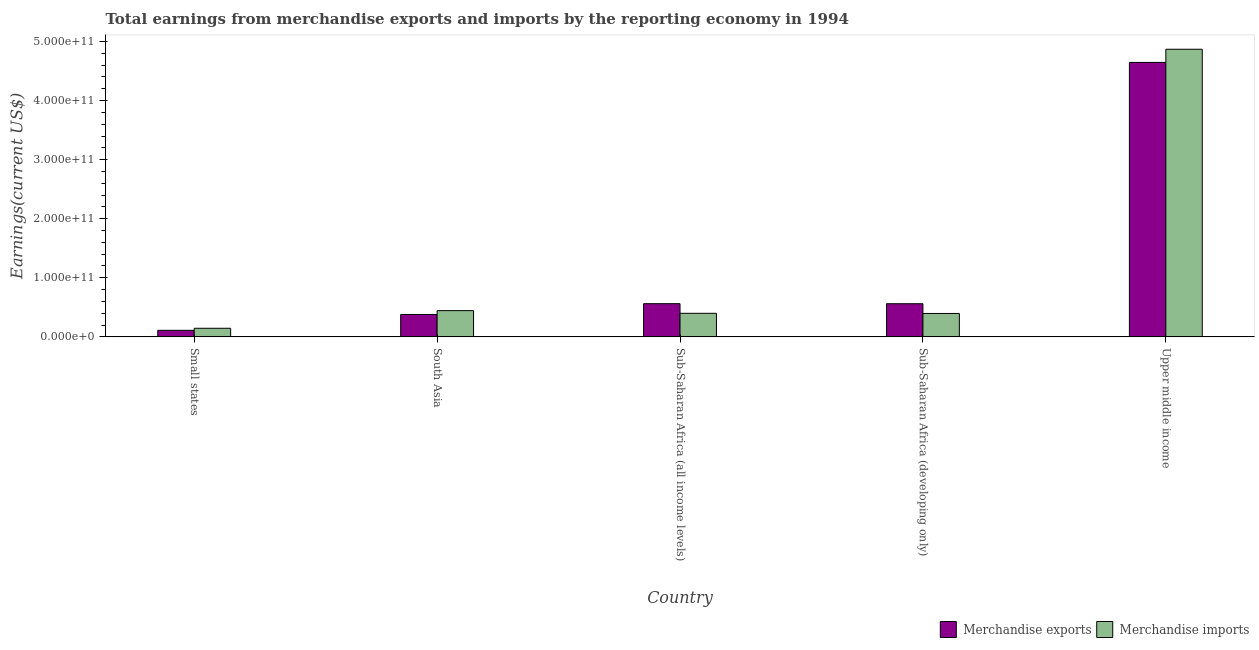Are the number of bars on each tick of the X-axis equal?
Your answer should be very brief. Yes. How many bars are there on the 3rd tick from the left?
Offer a very short reply. 2. What is the label of the 2nd group of bars from the left?
Make the answer very short. South Asia. What is the earnings from merchandise imports in Sub-Saharan Africa (developing only)?
Offer a terse response. 3.96e+1. Across all countries, what is the maximum earnings from merchandise imports?
Your response must be concise. 4.87e+11. Across all countries, what is the minimum earnings from merchandise imports?
Offer a very short reply. 1.45e+1. In which country was the earnings from merchandise exports maximum?
Your response must be concise. Upper middle income. In which country was the earnings from merchandise imports minimum?
Your answer should be compact. Small states. What is the total earnings from merchandise imports in the graph?
Offer a very short reply. 6.25e+11. What is the difference between the earnings from merchandise imports in South Asia and that in Sub-Saharan Africa (all income levels)?
Ensure brevity in your answer.  4.53e+09. What is the difference between the earnings from merchandise imports in Sub-Saharan Africa (developing only) and the earnings from merchandise exports in South Asia?
Your answer should be very brief. 1.75e+09. What is the average earnings from merchandise exports per country?
Make the answer very short. 1.25e+11. What is the difference between the earnings from merchandise imports and earnings from merchandise exports in Sub-Saharan Africa (all income levels)?
Make the answer very short. -1.63e+1. What is the ratio of the earnings from merchandise exports in Small states to that in Sub-Saharan Africa (developing only)?
Give a very brief answer. 0.2. What is the difference between the highest and the second highest earnings from merchandise imports?
Ensure brevity in your answer.  4.42e+11. What is the difference between the highest and the lowest earnings from merchandise imports?
Keep it short and to the point. 4.72e+11. Is the sum of the earnings from merchandise imports in Small states and South Asia greater than the maximum earnings from merchandise exports across all countries?
Keep it short and to the point. No. What does the 1st bar from the left in Upper middle income represents?
Make the answer very short. Merchandise exports. Are all the bars in the graph horizontal?
Offer a terse response. No. What is the difference between two consecutive major ticks on the Y-axis?
Provide a succinct answer. 1.00e+11. Are the values on the major ticks of Y-axis written in scientific E-notation?
Your response must be concise. Yes. Does the graph contain any zero values?
Your response must be concise. No. Where does the legend appear in the graph?
Provide a short and direct response. Bottom right. How are the legend labels stacked?
Your answer should be compact. Horizontal. What is the title of the graph?
Your answer should be very brief. Total earnings from merchandise exports and imports by the reporting economy in 1994. Does "Young" appear as one of the legend labels in the graph?
Ensure brevity in your answer.  No. What is the label or title of the Y-axis?
Provide a succinct answer. Earnings(current US$). What is the Earnings(current US$) of Merchandise exports in Small states?
Keep it short and to the point. 1.11e+1. What is the Earnings(current US$) in Merchandise imports in Small states?
Ensure brevity in your answer.  1.45e+1. What is the Earnings(current US$) in Merchandise exports in South Asia?
Offer a terse response. 3.79e+1. What is the Earnings(current US$) of Merchandise imports in South Asia?
Offer a very short reply. 4.44e+1. What is the Earnings(current US$) in Merchandise exports in Sub-Saharan Africa (all income levels)?
Offer a very short reply. 5.62e+1. What is the Earnings(current US$) in Merchandise imports in Sub-Saharan Africa (all income levels)?
Ensure brevity in your answer.  3.99e+1. What is the Earnings(current US$) of Merchandise exports in Sub-Saharan Africa (developing only)?
Provide a succinct answer. 5.61e+1. What is the Earnings(current US$) in Merchandise imports in Sub-Saharan Africa (developing only)?
Offer a very short reply. 3.96e+1. What is the Earnings(current US$) in Merchandise exports in Upper middle income?
Make the answer very short. 4.65e+11. What is the Earnings(current US$) in Merchandise imports in Upper middle income?
Provide a succinct answer. 4.87e+11. Across all countries, what is the maximum Earnings(current US$) of Merchandise exports?
Provide a succinct answer. 4.65e+11. Across all countries, what is the maximum Earnings(current US$) in Merchandise imports?
Your answer should be very brief. 4.87e+11. Across all countries, what is the minimum Earnings(current US$) of Merchandise exports?
Your response must be concise. 1.11e+1. Across all countries, what is the minimum Earnings(current US$) in Merchandise imports?
Provide a short and direct response. 1.45e+1. What is the total Earnings(current US$) in Merchandise exports in the graph?
Make the answer very short. 6.26e+11. What is the total Earnings(current US$) of Merchandise imports in the graph?
Offer a very short reply. 6.25e+11. What is the difference between the Earnings(current US$) of Merchandise exports in Small states and that in South Asia?
Your answer should be compact. -2.68e+1. What is the difference between the Earnings(current US$) in Merchandise imports in Small states and that in South Asia?
Provide a succinct answer. -2.99e+1. What is the difference between the Earnings(current US$) of Merchandise exports in Small states and that in Sub-Saharan Africa (all income levels)?
Your answer should be very brief. -4.51e+1. What is the difference between the Earnings(current US$) in Merchandise imports in Small states and that in Sub-Saharan Africa (all income levels)?
Provide a succinct answer. -2.54e+1. What is the difference between the Earnings(current US$) in Merchandise exports in Small states and that in Sub-Saharan Africa (developing only)?
Keep it short and to the point. -4.51e+1. What is the difference between the Earnings(current US$) of Merchandise imports in Small states and that in Sub-Saharan Africa (developing only)?
Provide a succinct answer. -2.51e+1. What is the difference between the Earnings(current US$) of Merchandise exports in Small states and that in Upper middle income?
Provide a short and direct response. -4.54e+11. What is the difference between the Earnings(current US$) in Merchandise imports in Small states and that in Upper middle income?
Your answer should be compact. -4.72e+11. What is the difference between the Earnings(current US$) in Merchandise exports in South Asia and that in Sub-Saharan Africa (all income levels)?
Your response must be concise. -1.83e+1. What is the difference between the Earnings(current US$) of Merchandise imports in South Asia and that in Sub-Saharan Africa (all income levels)?
Make the answer very short. 4.53e+09. What is the difference between the Earnings(current US$) in Merchandise exports in South Asia and that in Sub-Saharan Africa (developing only)?
Keep it short and to the point. -1.82e+1. What is the difference between the Earnings(current US$) in Merchandise imports in South Asia and that in Sub-Saharan Africa (developing only)?
Provide a short and direct response. 4.80e+09. What is the difference between the Earnings(current US$) in Merchandise exports in South Asia and that in Upper middle income?
Provide a succinct answer. -4.27e+11. What is the difference between the Earnings(current US$) in Merchandise imports in South Asia and that in Upper middle income?
Keep it short and to the point. -4.42e+11. What is the difference between the Earnings(current US$) in Merchandise exports in Sub-Saharan Africa (all income levels) and that in Sub-Saharan Africa (developing only)?
Offer a terse response. 7.79e+07. What is the difference between the Earnings(current US$) of Merchandise imports in Sub-Saharan Africa (all income levels) and that in Sub-Saharan Africa (developing only)?
Offer a terse response. 2.71e+08. What is the difference between the Earnings(current US$) of Merchandise exports in Sub-Saharan Africa (all income levels) and that in Upper middle income?
Keep it short and to the point. -4.08e+11. What is the difference between the Earnings(current US$) of Merchandise imports in Sub-Saharan Africa (all income levels) and that in Upper middle income?
Offer a terse response. -4.47e+11. What is the difference between the Earnings(current US$) of Merchandise exports in Sub-Saharan Africa (developing only) and that in Upper middle income?
Your answer should be compact. -4.09e+11. What is the difference between the Earnings(current US$) in Merchandise imports in Sub-Saharan Africa (developing only) and that in Upper middle income?
Give a very brief answer. -4.47e+11. What is the difference between the Earnings(current US$) of Merchandise exports in Small states and the Earnings(current US$) of Merchandise imports in South Asia?
Your response must be concise. -3.34e+1. What is the difference between the Earnings(current US$) of Merchandise exports in Small states and the Earnings(current US$) of Merchandise imports in Sub-Saharan Africa (all income levels)?
Your answer should be very brief. -2.88e+1. What is the difference between the Earnings(current US$) in Merchandise exports in Small states and the Earnings(current US$) in Merchandise imports in Sub-Saharan Africa (developing only)?
Keep it short and to the point. -2.86e+1. What is the difference between the Earnings(current US$) in Merchandise exports in Small states and the Earnings(current US$) in Merchandise imports in Upper middle income?
Give a very brief answer. -4.76e+11. What is the difference between the Earnings(current US$) of Merchandise exports in South Asia and the Earnings(current US$) of Merchandise imports in Sub-Saharan Africa (all income levels)?
Your response must be concise. -2.02e+09. What is the difference between the Earnings(current US$) in Merchandise exports in South Asia and the Earnings(current US$) in Merchandise imports in Sub-Saharan Africa (developing only)?
Give a very brief answer. -1.75e+09. What is the difference between the Earnings(current US$) of Merchandise exports in South Asia and the Earnings(current US$) of Merchandise imports in Upper middle income?
Give a very brief answer. -4.49e+11. What is the difference between the Earnings(current US$) of Merchandise exports in Sub-Saharan Africa (all income levels) and the Earnings(current US$) of Merchandise imports in Sub-Saharan Africa (developing only)?
Your answer should be compact. 1.66e+1. What is the difference between the Earnings(current US$) of Merchandise exports in Sub-Saharan Africa (all income levels) and the Earnings(current US$) of Merchandise imports in Upper middle income?
Give a very brief answer. -4.31e+11. What is the difference between the Earnings(current US$) in Merchandise exports in Sub-Saharan Africa (developing only) and the Earnings(current US$) in Merchandise imports in Upper middle income?
Your answer should be compact. -4.31e+11. What is the average Earnings(current US$) of Merchandise exports per country?
Provide a succinct answer. 1.25e+11. What is the average Earnings(current US$) of Merchandise imports per country?
Ensure brevity in your answer.  1.25e+11. What is the difference between the Earnings(current US$) in Merchandise exports and Earnings(current US$) in Merchandise imports in Small states?
Make the answer very short. -3.49e+09. What is the difference between the Earnings(current US$) of Merchandise exports and Earnings(current US$) of Merchandise imports in South Asia?
Your answer should be compact. -6.56e+09. What is the difference between the Earnings(current US$) in Merchandise exports and Earnings(current US$) in Merchandise imports in Sub-Saharan Africa (all income levels)?
Give a very brief answer. 1.63e+1. What is the difference between the Earnings(current US$) of Merchandise exports and Earnings(current US$) of Merchandise imports in Sub-Saharan Africa (developing only)?
Your response must be concise. 1.65e+1. What is the difference between the Earnings(current US$) of Merchandise exports and Earnings(current US$) of Merchandise imports in Upper middle income?
Provide a short and direct response. -2.23e+1. What is the ratio of the Earnings(current US$) in Merchandise exports in Small states to that in South Asia?
Offer a terse response. 0.29. What is the ratio of the Earnings(current US$) in Merchandise imports in Small states to that in South Asia?
Offer a terse response. 0.33. What is the ratio of the Earnings(current US$) of Merchandise exports in Small states to that in Sub-Saharan Africa (all income levels)?
Ensure brevity in your answer.  0.2. What is the ratio of the Earnings(current US$) in Merchandise imports in Small states to that in Sub-Saharan Africa (all income levels)?
Offer a very short reply. 0.36. What is the ratio of the Earnings(current US$) of Merchandise exports in Small states to that in Sub-Saharan Africa (developing only)?
Ensure brevity in your answer.  0.2. What is the ratio of the Earnings(current US$) of Merchandise imports in Small states to that in Sub-Saharan Africa (developing only)?
Provide a short and direct response. 0.37. What is the ratio of the Earnings(current US$) of Merchandise exports in Small states to that in Upper middle income?
Your answer should be compact. 0.02. What is the ratio of the Earnings(current US$) of Merchandise imports in Small states to that in Upper middle income?
Offer a very short reply. 0.03. What is the ratio of the Earnings(current US$) of Merchandise exports in South Asia to that in Sub-Saharan Africa (all income levels)?
Offer a terse response. 0.67. What is the ratio of the Earnings(current US$) in Merchandise imports in South Asia to that in Sub-Saharan Africa (all income levels)?
Make the answer very short. 1.11. What is the ratio of the Earnings(current US$) of Merchandise exports in South Asia to that in Sub-Saharan Africa (developing only)?
Offer a terse response. 0.68. What is the ratio of the Earnings(current US$) of Merchandise imports in South Asia to that in Sub-Saharan Africa (developing only)?
Make the answer very short. 1.12. What is the ratio of the Earnings(current US$) of Merchandise exports in South Asia to that in Upper middle income?
Offer a very short reply. 0.08. What is the ratio of the Earnings(current US$) of Merchandise imports in South Asia to that in Upper middle income?
Your answer should be compact. 0.09. What is the ratio of the Earnings(current US$) of Merchandise exports in Sub-Saharan Africa (all income levels) to that in Sub-Saharan Africa (developing only)?
Keep it short and to the point. 1. What is the ratio of the Earnings(current US$) in Merchandise imports in Sub-Saharan Africa (all income levels) to that in Sub-Saharan Africa (developing only)?
Provide a succinct answer. 1.01. What is the ratio of the Earnings(current US$) of Merchandise exports in Sub-Saharan Africa (all income levels) to that in Upper middle income?
Provide a succinct answer. 0.12. What is the ratio of the Earnings(current US$) in Merchandise imports in Sub-Saharan Africa (all income levels) to that in Upper middle income?
Your answer should be very brief. 0.08. What is the ratio of the Earnings(current US$) of Merchandise exports in Sub-Saharan Africa (developing only) to that in Upper middle income?
Give a very brief answer. 0.12. What is the ratio of the Earnings(current US$) in Merchandise imports in Sub-Saharan Africa (developing only) to that in Upper middle income?
Provide a short and direct response. 0.08. What is the difference between the highest and the second highest Earnings(current US$) in Merchandise exports?
Keep it short and to the point. 4.08e+11. What is the difference between the highest and the second highest Earnings(current US$) in Merchandise imports?
Offer a terse response. 4.42e+11. What is the difference between the highest and the lowest Earnings(current US$) of Merchandise exports?
Offer a very short reply. 4.54e+11. What is the difference between the highest and the lowest Earnings(current US$) of Merchandise imports?
Keep it short and to the point. 4.72e+11. 